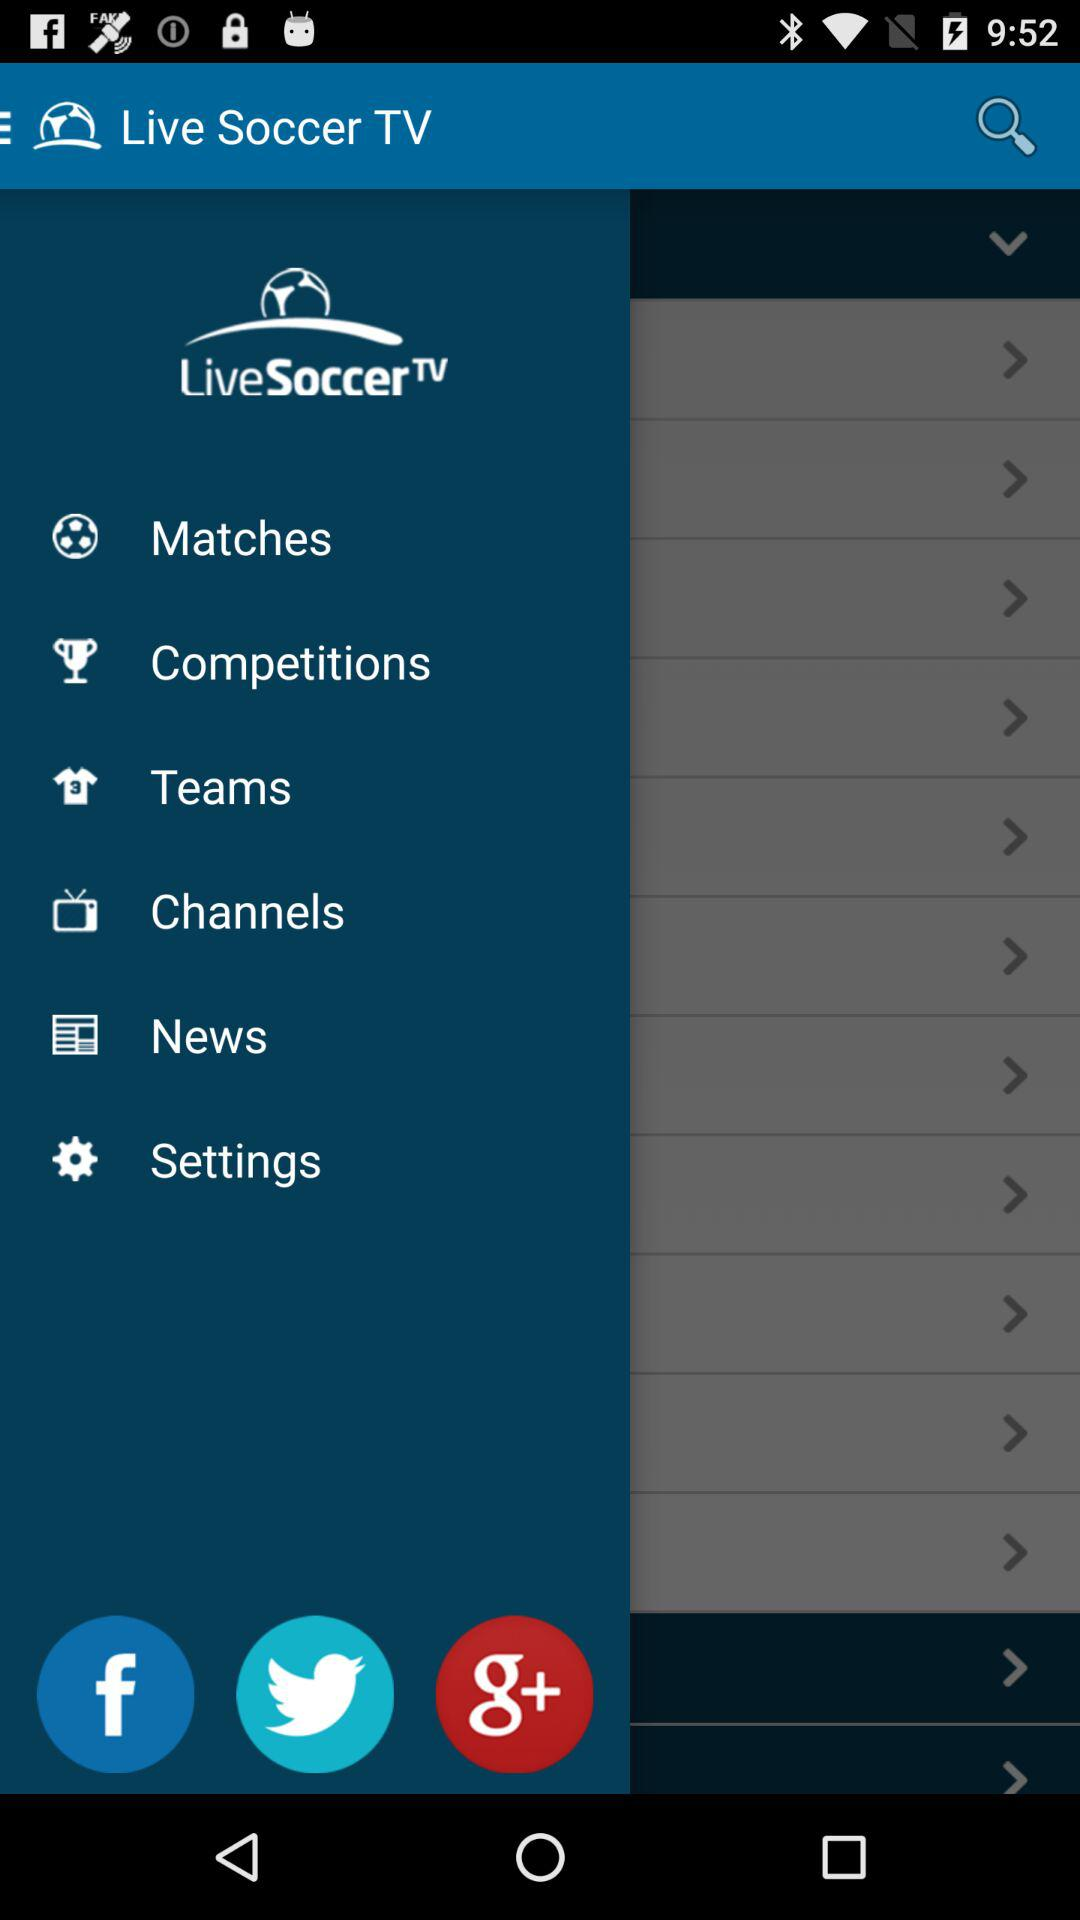What is the application name? The application name is "Live Soccer TV". 